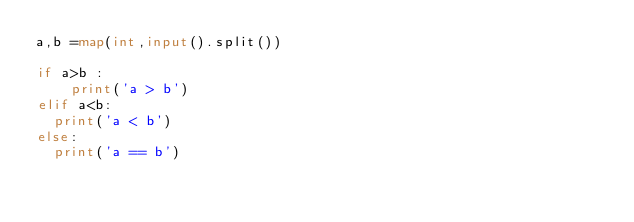<code> <loc_0><loc_0><loc_500><loc_500><_Python_>a,b =map(int,input().split())

if a>b :
    print('a > b')
elif a<b:
  print('a < b')
else:
  print('a == b')
</code> 